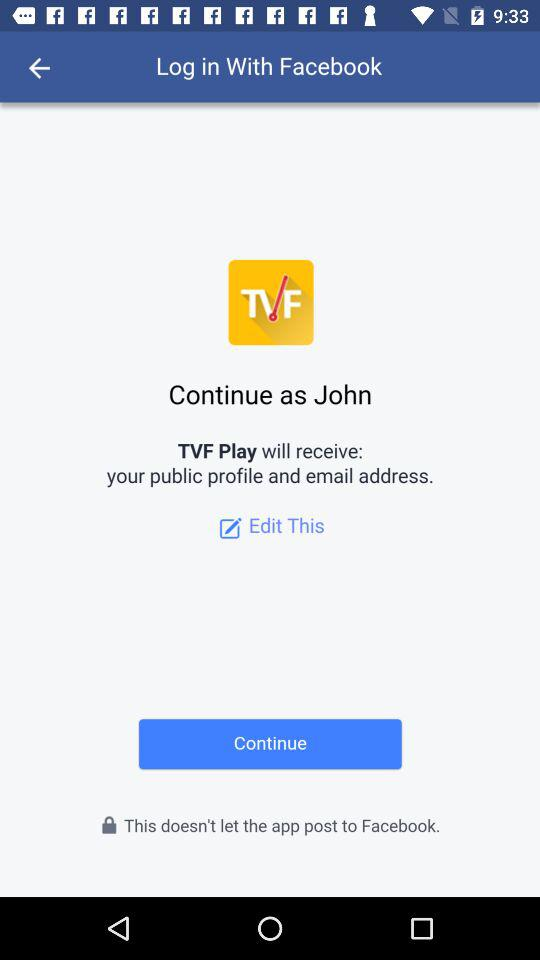What is the user name to continue on the login page? The user name to continue on the login page is John. 